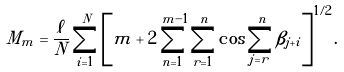Convert formula to latex. <formula><loc_0><loc_0><loc_500><loc_500>M _ { m } = \frac { \ell } { N } \sum _ { i = 1 } ^ { N } \left [ m + 2 \sum _ { n = 1 } ^ { m - 1 } \sum _ { r = 1 } ^ { n } \cos \sum _ { j = r } ^ { n } \beta _ { j + i } \right ] ^ { 1 / 2 } .</formula> 